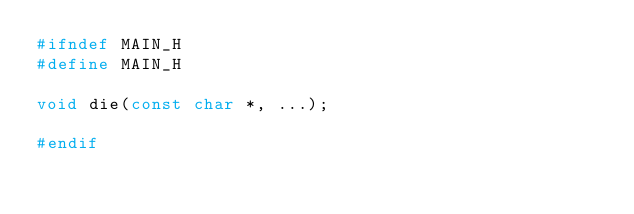Convert code to text. <code><loc_0><loc_0><loc_500><loc_500><_C_>#ifndef MAIN_H
#define MAIN_H

void die(const char *, ...);

#endif
</code> 